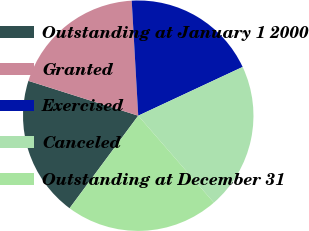Convert chart. <chart><loc_0><loc_0><loc_500><loc_500><pie_chart><fcel>Outstanding at January 1 2000<fcel>Granted<fcel>Exercised<fcel>Canceled<fcel>Outstanding at December 31<nl><fcel>19.73%<fcel>19.21%<fcel>18.95%<fcel>20.56%<fcel>21.55%<nl></chart> 